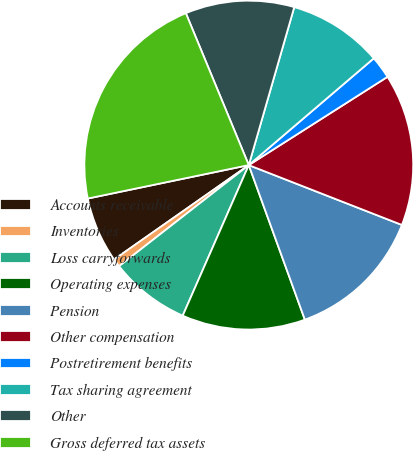<chart> <loc_0><loc_0><loc_500><loc_500><pie_chart><fcel>Accounts receivable<fcel>Inventories<fcel>Loss carryforwards<fcel>Operating expenses<fcel>Pension<fcel>Other compensation<fcel>Postretirement benefits<fcel>Tax sharing agreement<fcel>Other<fcel>Gross deferred tax assets<nl><fcel>6.47%<fcel>0.81%<fcel>7.88%<fcel>12.12%<fcel>13.53%<fcel>14.95%<fcel>2.23%<fcel>9.29%<fcel>10.71%<fcel>22.01%<nl></chart> 